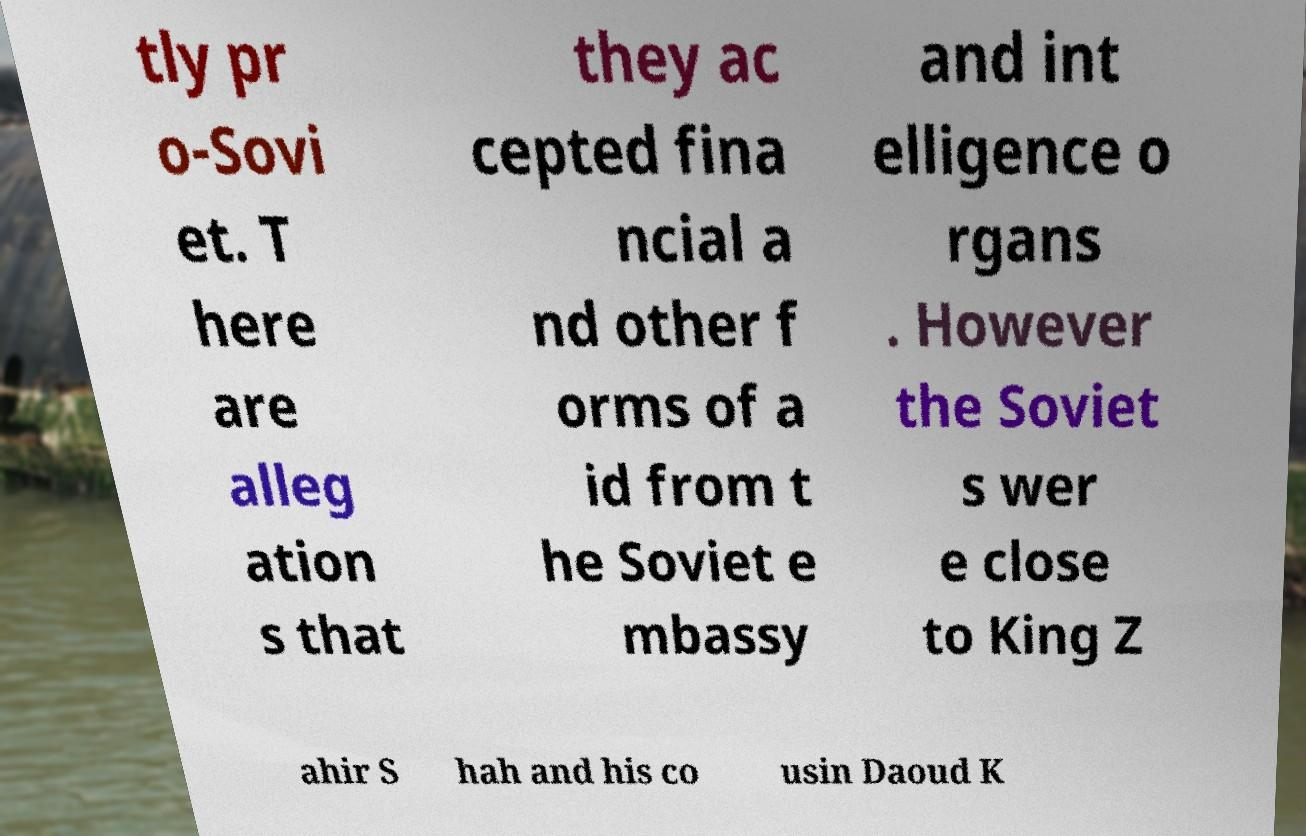Could you assist in decoding the text presented in this image and type it out clearly? tly pr o-Sovi et. T here are alleg ation s that they ac cepted fina ncial a nd other f orms of a id from t he Soviet e mbassy and int elligence o rgans . However the Soviet s wer e close to King Z ahir S hah and his co usin Daoud K 